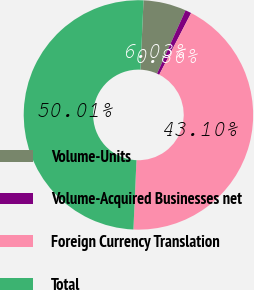<chart> <loc_0><loc_0><loc_500><loc_500><pie_chart><fcel>Volume-Units<fcel>Volume-Acquired Businesses net<fcel>Foreign Currency Translation<fcel>Total<nl><fcel>6.03%<fcel>0.86%<fcel>43.1%<fcel>50.0%<nl></chart> 